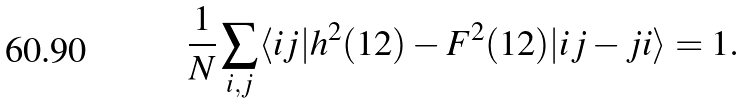Convert formula to latex. <formula><loc_0><loc_0><loc_500><loc_500>\frac { 1 } { N } \sum _ { i , j } \langle i j | h ^ { 2 } ( 1 2 ) - F ^ { 2 } ( 1 2 ) | i j - j i \rangle = 1 .</formula> 